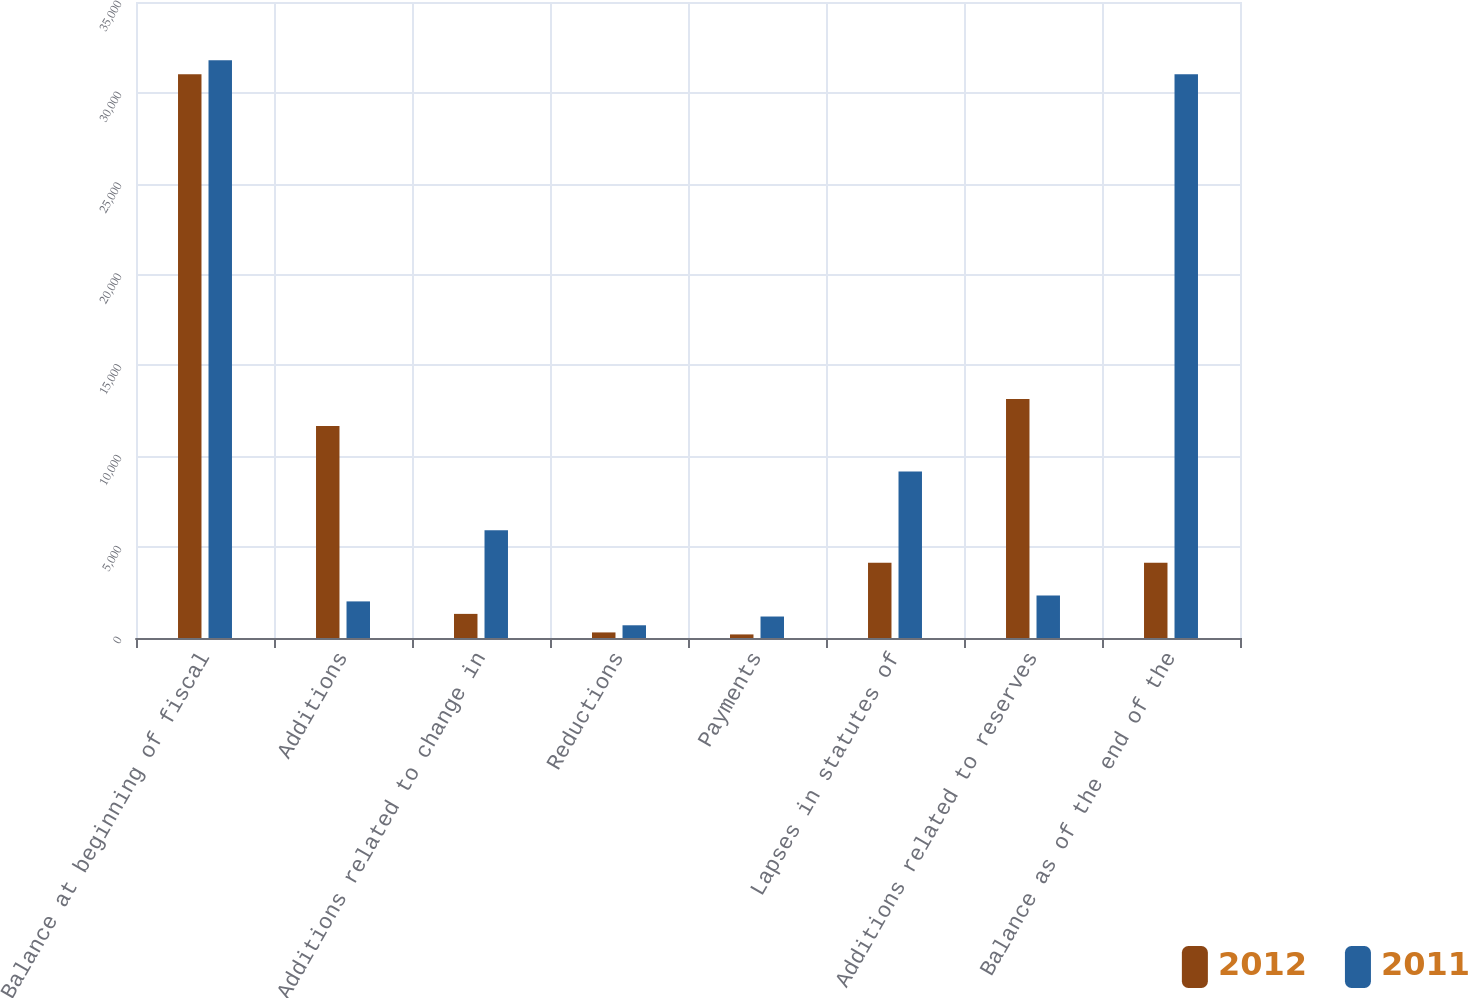Convert chart to OTSL. <chart><loc_0><loc_0><loc_500><loc_500><stacked_bar_chart><ecel><fcel>Balance at beginning of fiscal<fcel>Additions<fcel>Additions related to change in<fcel>Reductions<fcel>Payments<fcel>Lapses in statutes of<fcel>Additions related to reserves<fcel>Balance as of the end of the<nl><fcel>2012<fcel>31026<fcel>11673<fcel>1327<fcel>307<fcel>197<fcel>4144<fcel>13156<fcel>4144<nl><fcel>2011<fcel>31790<fcel>2014<fcel>5934<fcel>700<fcel>1182<fcel>9162<fcel>2332<fcel>31026<nl></chart> 